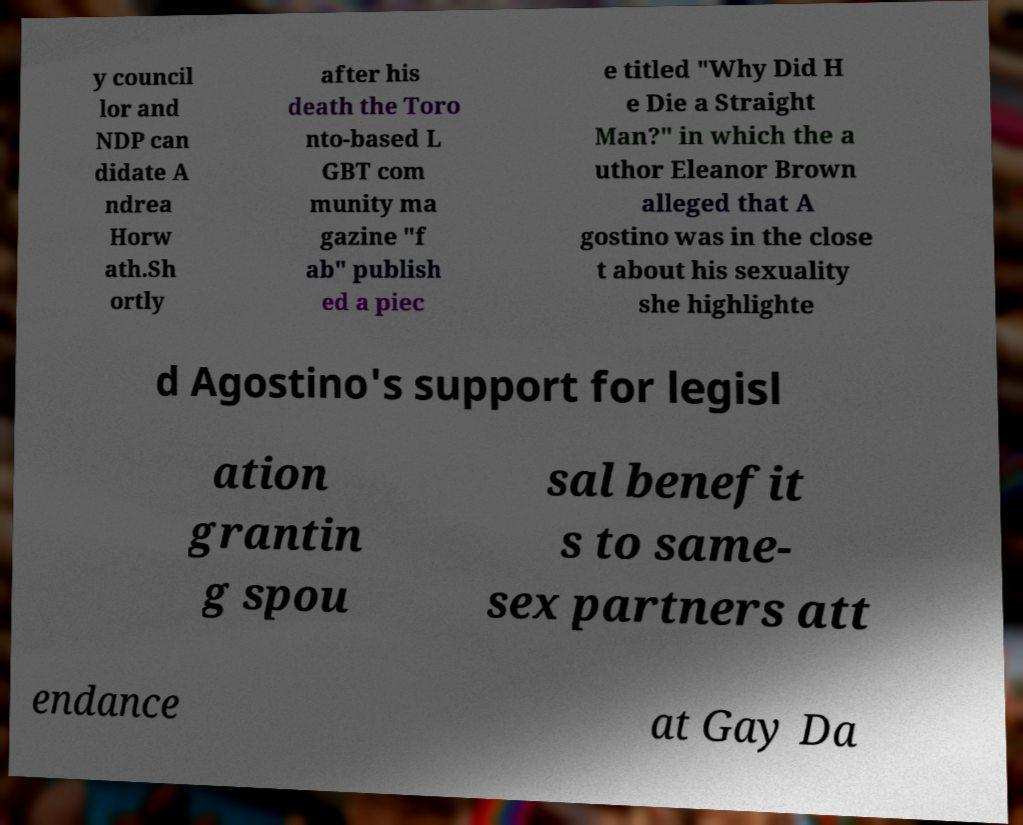What messages or text are displayed in this image? I need them in a readable, typed format. y council lor and NDP can didate A ndrea Horw ath.Sh ortly after his death the Toro nto-based L GBT com munity ma gazine "f ab" publish ed a piec e titled "Why Did H e Die a Straight Man?" in which the a uthor Eleanor Brown alleged that A gostino was in the close t about his sexuality she highlighte d Agostino's support for legisl ation grantin g spou sal benefit s to same- sex partners att endance at Gay Da 